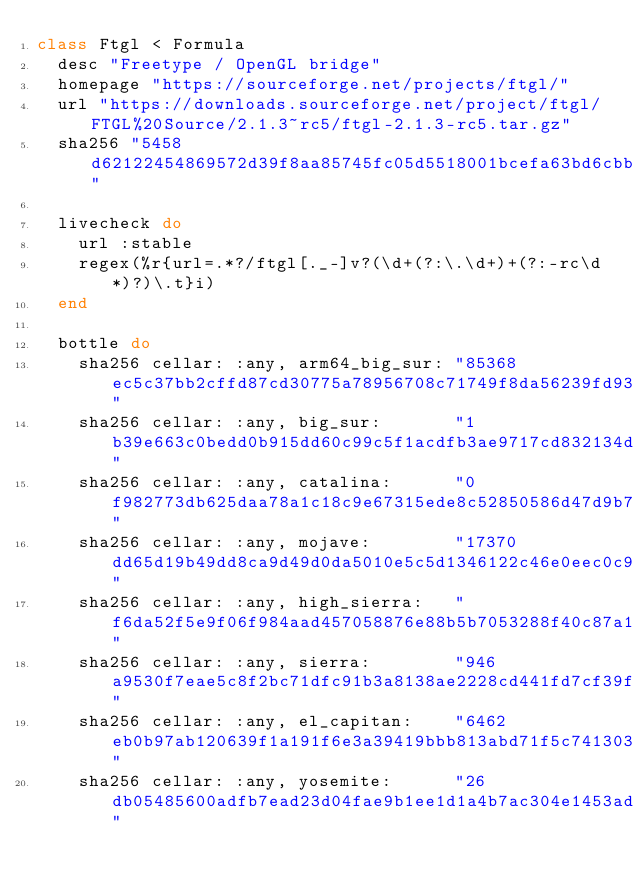<code> <loc_0><loc_0><loc_500><loc_500><_Ruby_>class Ftgl < Formula
  desc "Freetype / OpenGL bridge"
  homepage "https://sourceforge.net/projects/ftgl/"
  url "https://downloads.sourceforge.net/project/ftgl/FTGL%20Source/2.1.3~rc5/ftgl-2.1.3-rc5.tar.gz"
  sha256 "5458d62122454869572d39f8aa85745fc05d5518001bcefa63bd6cbb8d26565b"

  livecheck do
    url :stable
    regex(%r{url=.*?/ftgl[._-]v?(\d+(?:\.\d+)+(?:-rc\d*)?)\.t}i)
  end

  bottle do
    sha256 cellar: :any, arm64_big_sur: "85368ec5c37bb2cffd87cd30775a78956708c71749f8da56239fd93e57cf576d"
    sha256 cellar: :any, big_sur:       "1b39e663c0bedd0b915dd60c99c5f1acdfb3ae9717cd832134de15fd48736673"
    sha256 cellar: :any, catalina:      "0f982773db625daa78a1c18c9e67315ede8c52850586d47d9b7a41ffcac91730"
    sha256 cellar: :any, mojave:        "17370dd65d19b49dd8ca9d49d0da5010e5c5d1346122c46e0eec0c98b010fb13"
    sha256 cellar: :any, high_sierra:   "f6da52f5e9f06f984aad457058876e88b5b7053288f40c87a17d7d5749936cd6"
    sha256 cellar: :any, sierra:        "946a9530f7eae5c8f2bc71dfc91b3a8138ae2228cd441fd7cf39f047b957ce47"
    sha256 cellar: :any, el_capitan:    "6462eb0b97ab120639f1a191f6e3a39419bbb813abd71f5c741303dbf0aed7fb"
    sha256 cellar: :any, yosemite:      "26db05485600adfb7ead23d04fae9b1ee1d1a4b7ac304e1453ad83b4b2c39f64"</code> 